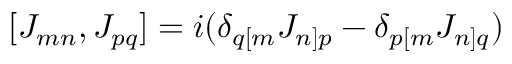<formula> <loc_0><loc_0><loc_500><loc_500>[ J _ { m n } , J _ { p q } ] = i ( \delta _ { q [ m } J _ { n ] p } - \delta _ { p [ m } J _ { n ] q } )</formula> 